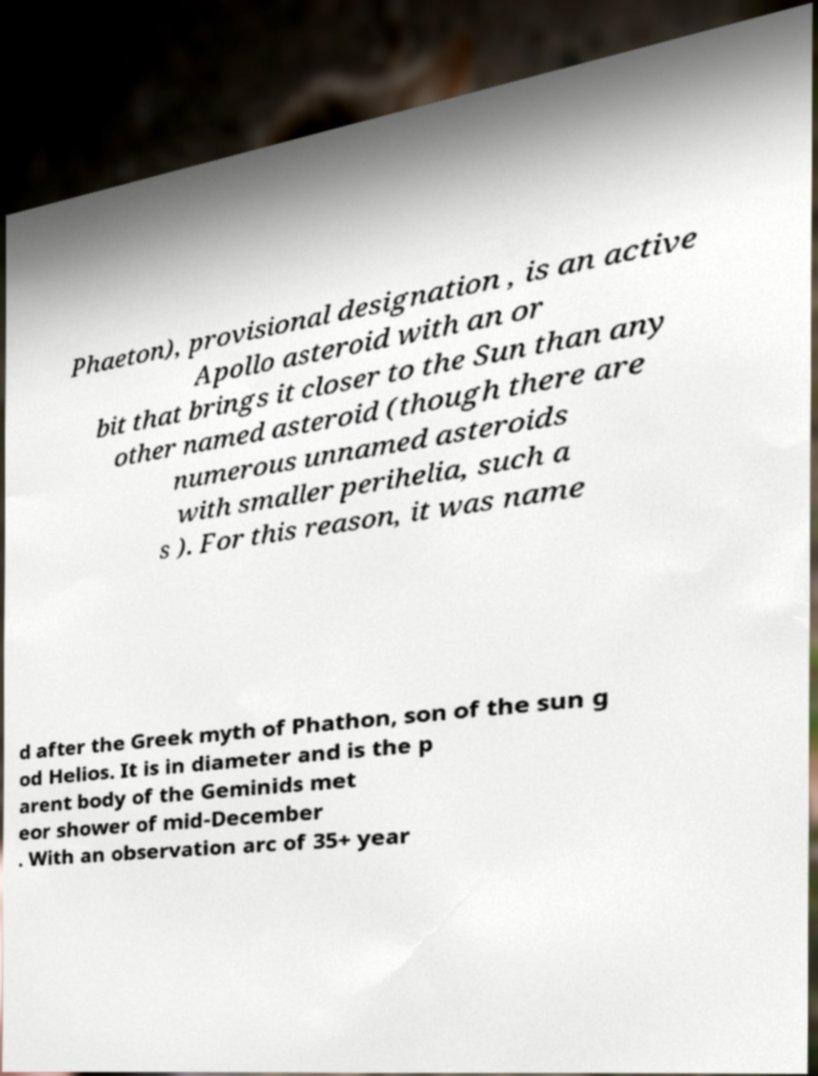Please identify and transcribe the text found in this image. Phaeton), provisional designation , is an active Apollo asteroid with an or bit that brings it closer to the Sun than any other named asteroid (though there are numerous unnamed asteroids with smaller perihelia, such a s ). For this reason, it was name d after the Greek myth of Phathon, son of the sun g od Helios. It is in diameter and is the p arent body of the Geminids met eor shower of mid-December . With an observation arc of 35+ year 